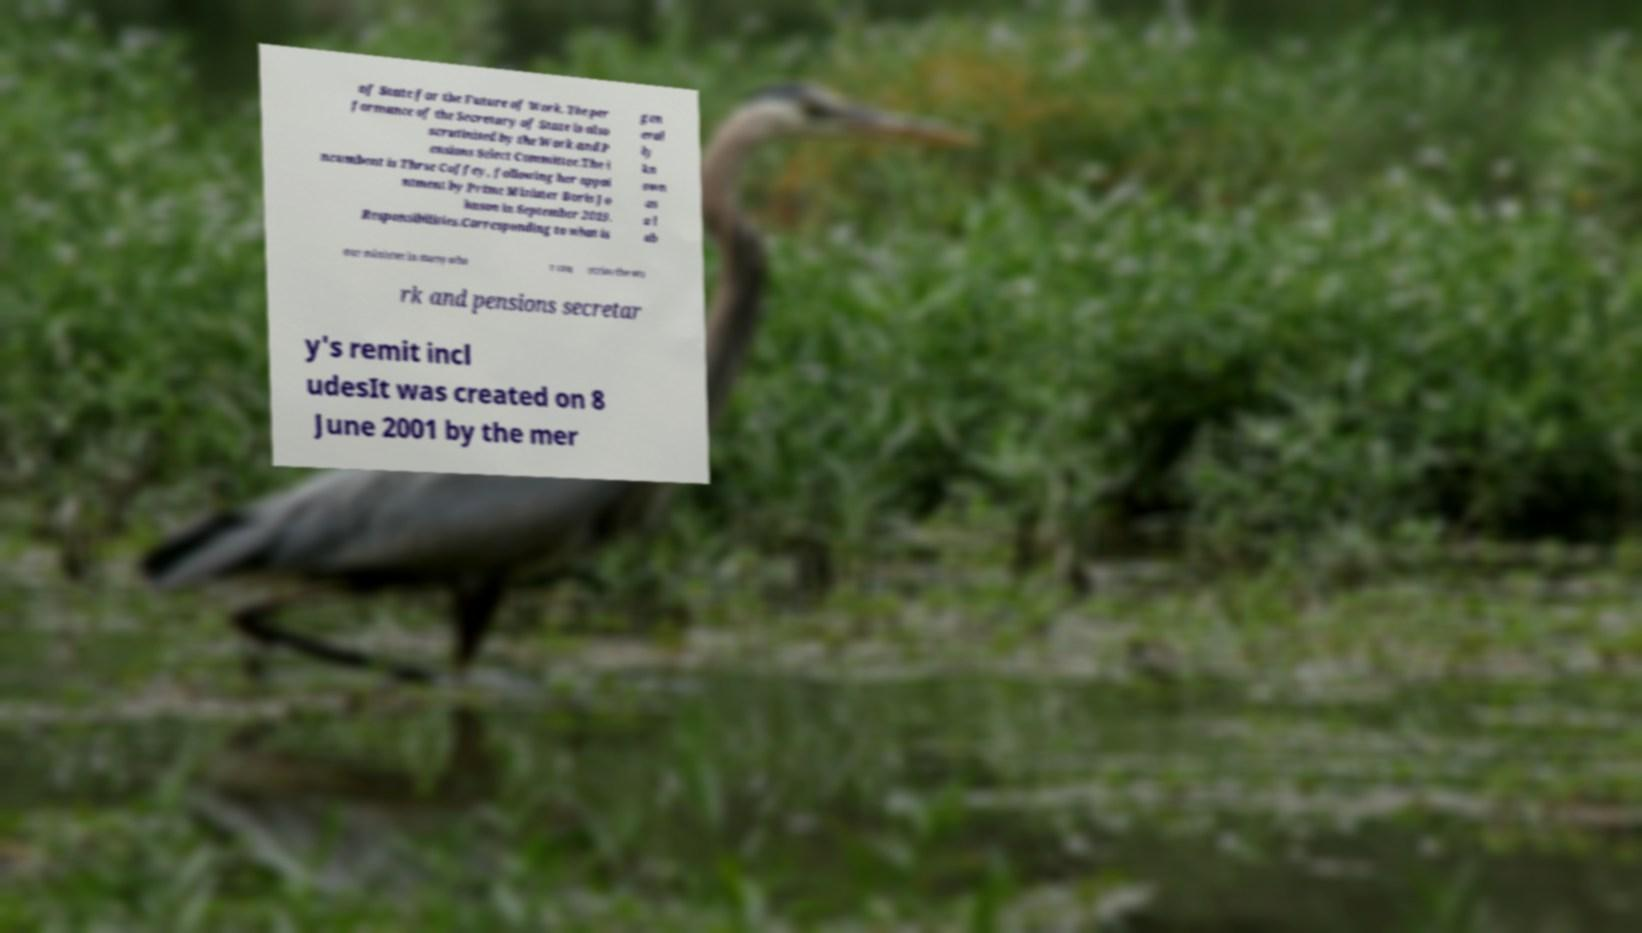Please read and relay the text visible in this image. What does it say? of State for the Future of Work. The per formance of the Secretary of State is also scrutinised by the Work and P ensions Select Committee.The i ncumbent is Thrse Coffey, following her appoi ntment by Prime Minister Boris Jo hnson in September 2019. Responsibilities.Corresponding to what is gen eral ly kn own as a l ab our minister in many othe r cou ntries the wo rk and pensions secretar y's remit incl udesIt was created on 8 June 2001 by the mer 